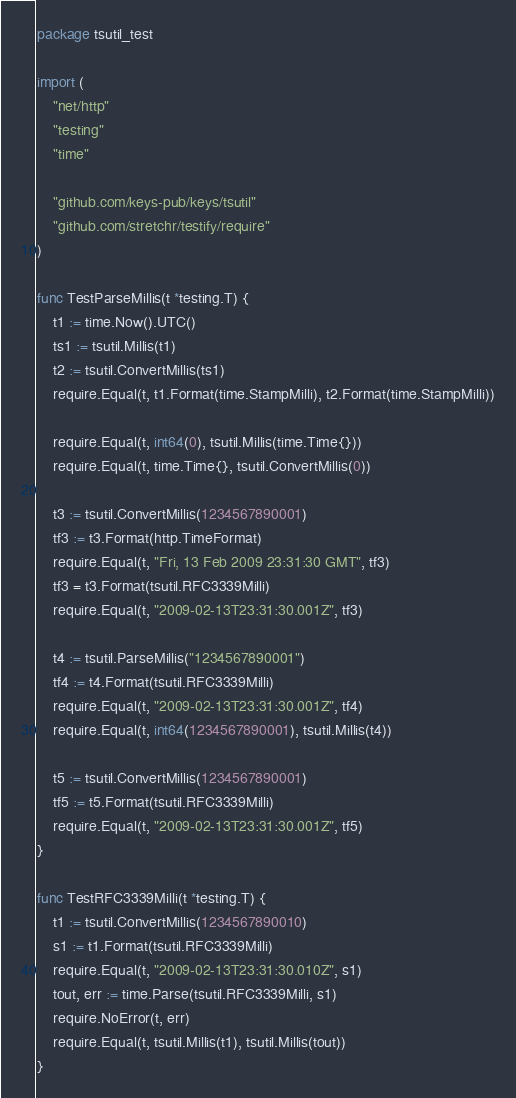Convert code to text. <code><loc_0><loc_0><loc_500><loc_500><_Go_>package tsutil_test

import (
	"net/http"
	"testing"
	"time"

	"github.com/keys-pub/keys/tsutil"
	"github.com/stretchr/testify/require"
)

func TestParseMillis(t *testing.T) {
	t1 := time.Now().UTC()
	ts1 := tsutil.Millis(t1)
	t2 := tsutil.ConvertMillis(ts1)
	require.Equal(t, t1.Format(time.StampMilli), t2.Format(time.StampMilli))

	require.Equal(t, int64(0), tsutil.Millis(time.Time{}))
	require.Equal(t, time.Time{}, tsutil.ConvertMillis(0))

	t3 := tsutil.ConvertMillis(1234567890001)
	tf3 := t3.Format(http.TimeFormat)
	require.Equal(t, "Fri, 13 Feb 2009 23:31:30 GMT", tf3)
	tf3 = t3.Format(tsutil.RFC3339Milli)
	require.Equal(t, "2009-02-13T23:31:30.001Z", tf3)

	t4 := tsutil.ParseMillis("1234567890001")
	tf4 := t4.Format(tsutil.RFC3339Milli)
	require.Equal(t, "2009-02-13T23:31:30.001Z", tf4)
	require.Equal(t, int64(1234567890001), tsutil.Millis(t4))

	t5 := tsutil.ConvertMillis(1234567890001)
	tf5 := t5.Format(tsutil.RFC3339Milli)
	require.Equal(t, "2009-02-13T23:31:30.001Z", tf5)
}

func TestRFC3339Milli(t *testing.T) {
	t1 := tsutil.ConvertMillis(1234567890010)
	s1 := t1.Format(tsutil.RFC3339Milli)
	require.Equal(t, "2009-02-13T23:31:30.010Z", s1)
	tout, err := time.Parse(tsutil.RFC3339Milli, s1)
	require.NoError(t, err)
	require.Equal(t, tsutil.Millis(t1), tsutil.Millis(tout))
}
</code> 